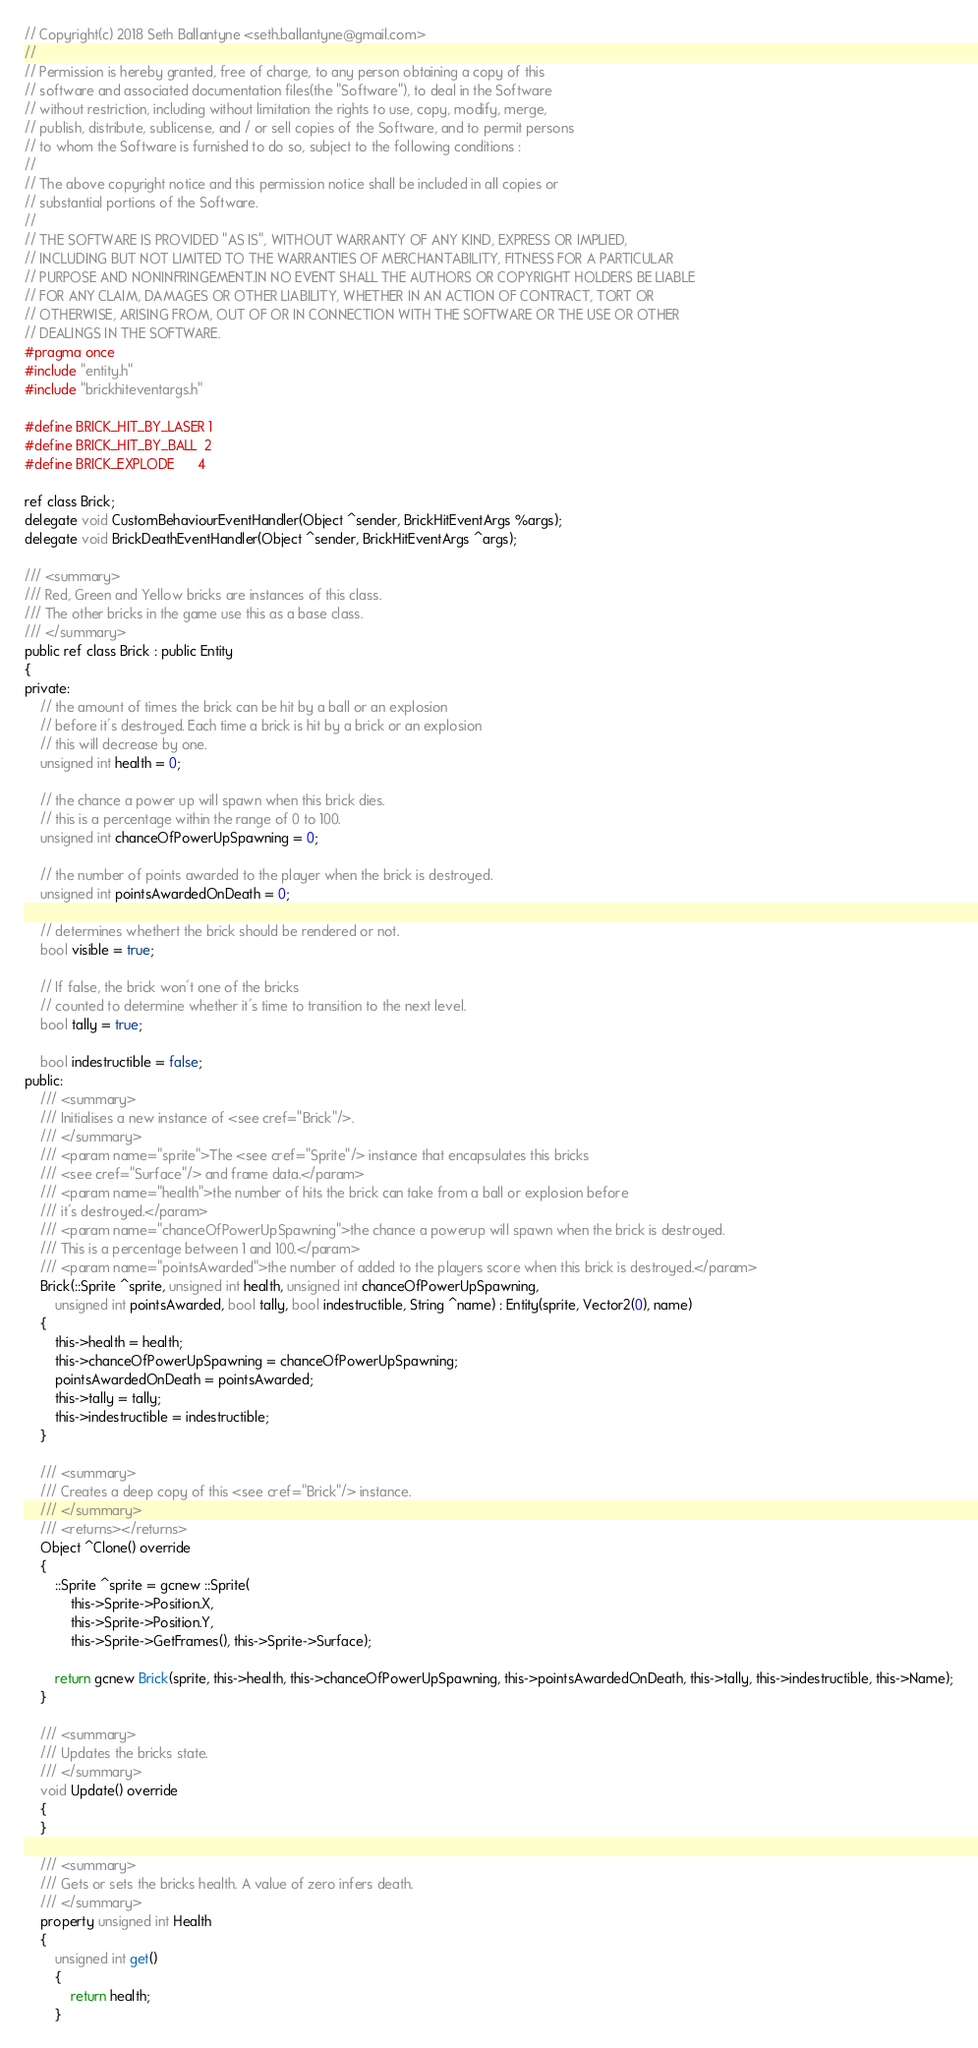<code> <loc_0><loc_0><loc_500><loc_500><_C_>// Copyright(c) 2018 Seth Ballantyne <seth.ballantyne@gmail.com>
//
// Permission is hereby granted, free of charge, to any person obtaining a copy of this
// software and associated documentation files(the "Software"), to deal in the Software
// without restriction, including without limitation the rights to use, copy, modify, merge,
// publish, distribute, sublicense, and / or sell copies of the Software, and to permit persons
// to whom the Software is furnished to do so, subject to the following conditions :
//
// The above copyright notice and this permission notice shall be included in all copies or
// substantial portions of the Software.
//
// THE SOFTWARE IS PROVIDED "AS IS", WITHOUT WARRANTY OF ANY KIND, EXPRESS OR IMPLIED,
// INCLUDING BUT NOT LIMITED TO THE WARRANTIES OF MERCHANTABILITY, FITNESS FOR A PARTICULAR
// PURPOSE AND NONINFRINGEMENT.IN NO EVENT SHALL THE AUTHORS OR COPYRIGHT HOLDERS BE LIABLE
// FOR ANY CLAIM, DAMAGES OR OTHER LIABILITY, WHETHER IN AN ACTION OF CONTRACT, TORT OR
// OTHERWISE, ARISING FROM, OUT OF OR IN CONNECTION WITH THE SOFTWARE OR THE USE OR OTHER
// DEALINGS IN THE SOFTWARE.
#pragma once
#include "entity.h"
#include "brickhiteventargs.h"

#define BRICK_HIT_BY_LASER 1
#define BRICK_HIT_BY_BALL  2
#define BRICK_EXPLODE      4

ref class Brick;
delegate void CustomBehaviourEventHandler(Object ^sender, BrickHitEventArgs %args);
delegate void BrickDeathEventHandler(Object ^sender, BrickHitEventArgs ^args);

/// <summary>
/// Red, Green and Yellow bricks are instances of this class.
/// The other bricks in the game use this as a base class.
/// </summary>
public ref class Brick : public Entity
{
private:
    // the amount of times the brick can be hit by a ball or an explosion
    // before it's destroyed. Each time a brick is hit by a brick or an explosion
    // this will decrease by one.
    unsigned int health = 0;

    // the chance a power up will spawn when this brick dies.
    // this is a percentage within the range of 0 to 100.
    unsigned int chanceOfPowerUpSpawning = 0;

    // the number of points awarded to the player when the brick is destroyed.
    unsigned int pointsAwardedOnDeath = 0;

	// determines whethert the brick should be rendered or not.
	bool visible = true;

	// If false, the brick won't one of the bricks
	// counted to determine whether it's time to transition to the next level.
	bool tally = true;

	bool indestructible = false;
public:
    /// <summary>
    /// Initialises a new instance of <see cref="Brick"/>.
    /// </summary>
    /// <param name="sprite">The <see cref="Sprite"/> instance that encapsulates this bricks 
    /// <see cref="Surface"/> and frame data.</param>
    /// <param name="health">the number of hits the brick can take from a ball or explosion before
    /// it's destroyed.</param>
    /// <param name="chanceOfPowerUpSpawning">the chance a powerup will spawn when the brick is destroyed. 
    /// This is a percentage between 1 and 100.</param>
    /// <param name="pointsAwarded">the number of added to the players score when this brick is destroyed.</param>
    Brick(::Sprite ^sprite, unsigned int health, unsigned int chanceOfPowerUpSpawning, 
        unsigned int pointsAwarded, bool tally, bool indestructible, String ^name) : Entity(sprite, Vector2(0), name)
    {
        this->health = health;
        this->chanceOfPowerUpSpawning = chanceOfPowerUpSpawning;
        pointsAwardedOnDeath = pointsAwarded;
		this->tally = tally;
		this->indestructible = indestructible;
    }

    /// <summary>
    /// Creates a deep copy of this <see cref="Brick"/> instance.
    /// </summary>
    /// <returns></returns>
    Object ^Clone() override
    {
        ::Sprite ^sprite = gcnew ::Sprite(
            this->Sprite->Position.X, 
            this->Sprite->Position.Y, 
            this->Sprite->GetFrames(), this->Sprite->Surface);

        return gcnew Brick(sprite, this->health, this->chanceOfPowerUpSpawning, this->pointsAwardedOnDeath, this->tally, this->indestructible, this->Name);
    }

    /// <summary>
    /// Updates the bricks state.
    /// </summary>
    void Update() override
    {
    }

    /// <summary>
    /// Gets or sets the bricks health. A value of zero infers death.
    /// </summary>
    property unsigned int Health
    {
        unsigned int get()
        {
            return health;
        }
</code> 